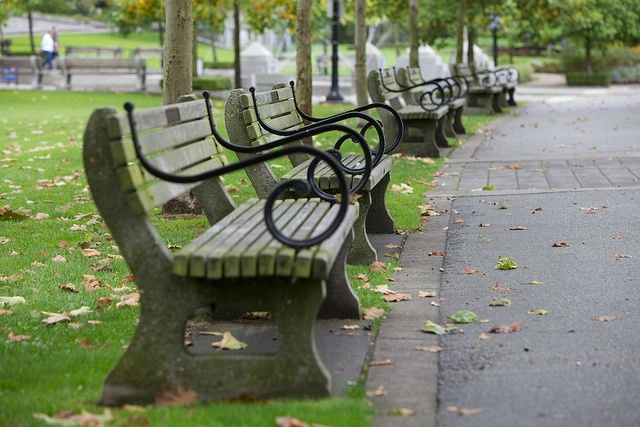Describe the objects in this image and their specific colors. I can see bench in olive, black, darkgreen, gray, and darkgray tones, bench in olive, black, gray, darkgray, and darkgreen tones, bench in olive, black, gray, darkgray, and darkgreen tones, bench in olive, gray, black, darkgray, and darkgreen tones, and bench in olive, darkgray, and gray tones in this image. 